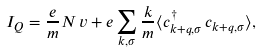<formula> <loc_0><loc_0><loc_500><loc_500>I _ { Q } = \frac { e } { m } N \, v + e \sum _ { k , \sigma } \frac { k } { m } \langle c _ { k + q , \sigma } ^ { \dagger } \, c _ { k + q , \sigma } \rangle ,</formula> 